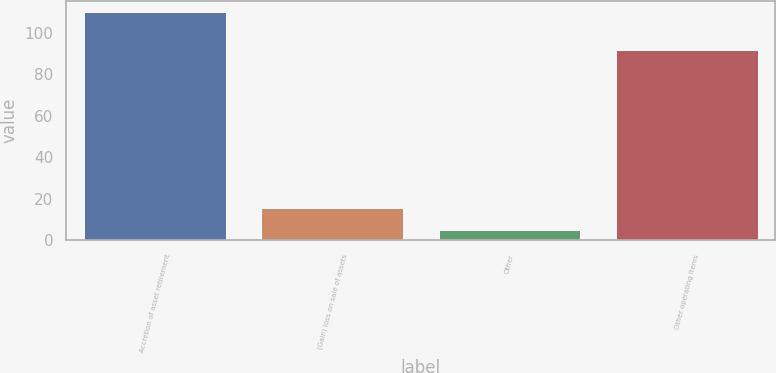Convert chart to OTSL. <chart><loc_0><loc_0><loc_500><loc_500><bar_chart><fcel>Accretion of asset retirement<fcel>(Gain) loss on sale of assets<fcel>Other<fcel>Other operating items<nl><fcel>110<fcel>15.5<fcel>5<fcel>92<nl></chart> 